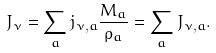<formula> <loc_0><loc_0><loc_500><loc_500>J _ { \nu } = \sum _ { a } j _ { \nu , a } \frac { M _ { a } } { \rho _ { a } } = \sum _ { a } J _ { \nu , a } .</formula> 